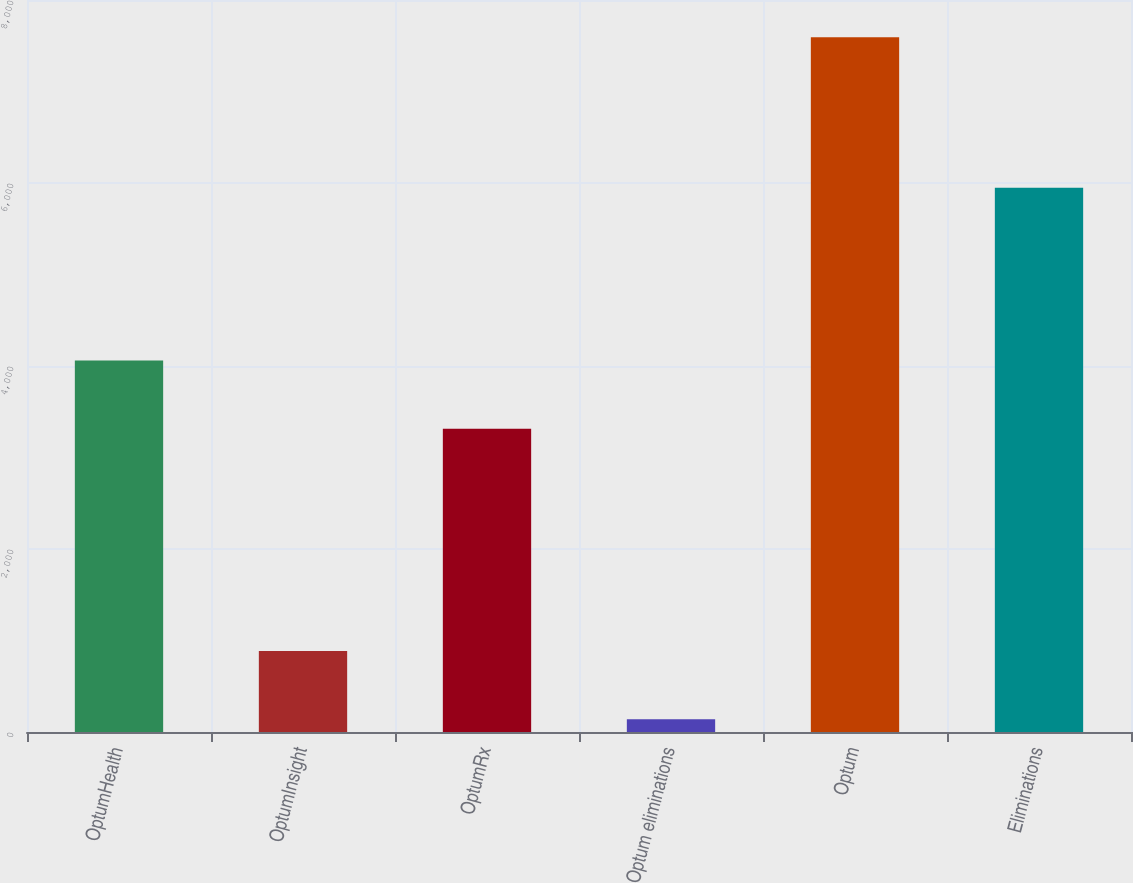Convert chart. <chart><loc_0><loc_0><loc_500><loc_500><bar_chart><fcel>OptumHealth<fcel>OptumInsight<fcel>OptumRx<fcel>Optum eliminations<fcel>Optum<fcel>Eliminations<nl><fcel>4060.3<fcel>884.3<fcel>3315<fcel>139<fcel>7592<fcel>5949<nl></chart> 